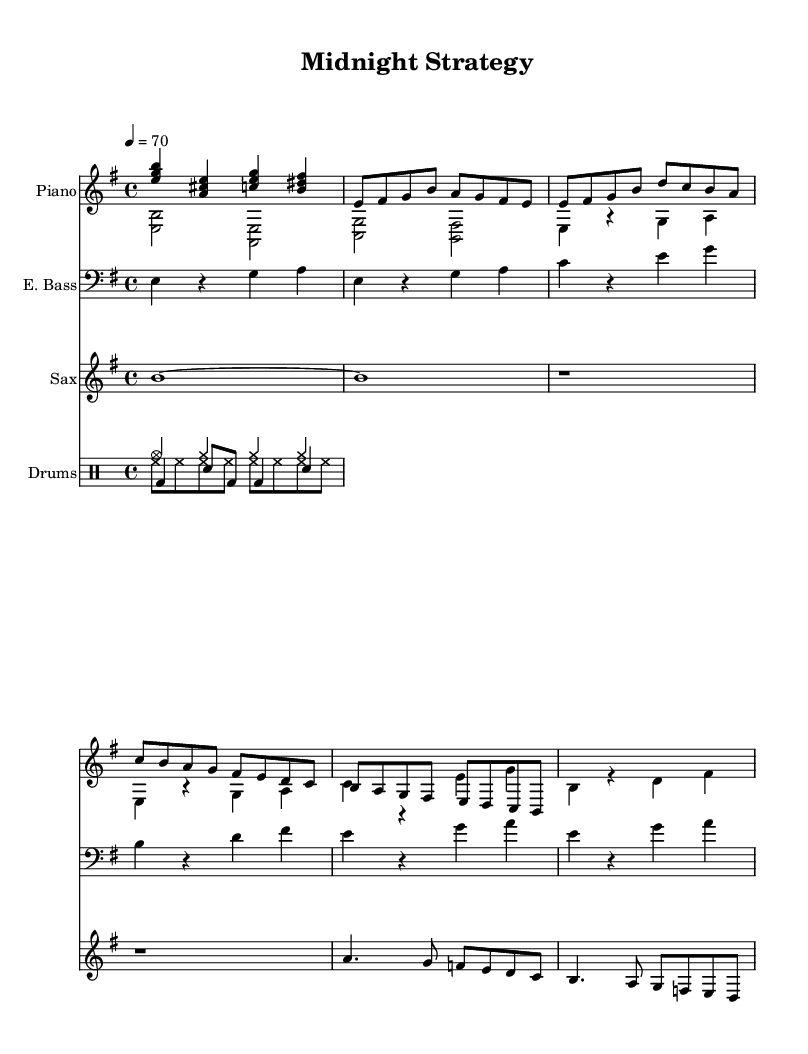What is the key signature of this music? The key signature is E minor, which has one sharp (F#). This is indicated at the beginning of the score.
Answer: E minor What is the time signature of this music? The time signature is 4/4, which means there are four beats in a measure and the quarter note gets one beat. This is noted at the beginning of the score.
Answer: 4/4 What is the tempo marking of this music? The tempo marking is 4 = 70, indicating a moderate pace of 70 beats per minute. This is specified at the beginning of the score under the tempo indication.
Answer: 70 How many measures are there in the intro section? To determine the number of measures, we look at the intro part of the score where the specific intro notes are presented. It has a total of four measures: each grouping of notes separated by a vertical line represents one measure.
Answer: 4 What is the leading note in the chorus? In the context of the E minor key, the leading note, which is the seventh scale degree, is D#. To confirm, we look at the chorus section and identify the note that creates tension that resolves back to the tonic E.
Answer: D# What instruments are used in this piece? The instruments listed in the score include Piano, Electric Bass, Saxophone, and Drums. Each instrument is clearly labeled at the beginning of its respective staff.
Answer: Piano, Electric Bass, Saxophone, Drums What is the rhythmic structure of the drum pattern? The drum pattern consists of a combination of cymbals, hi-hats, bass drum, and snare drum, presented in a four-beat cycle. Each beat's subdivision specifies the rhythms played in those beats, leading to a structured percussive feel suitable for R&B.
Answer: Combination of cymbals, hi-hats, bass drum, and snare drum 